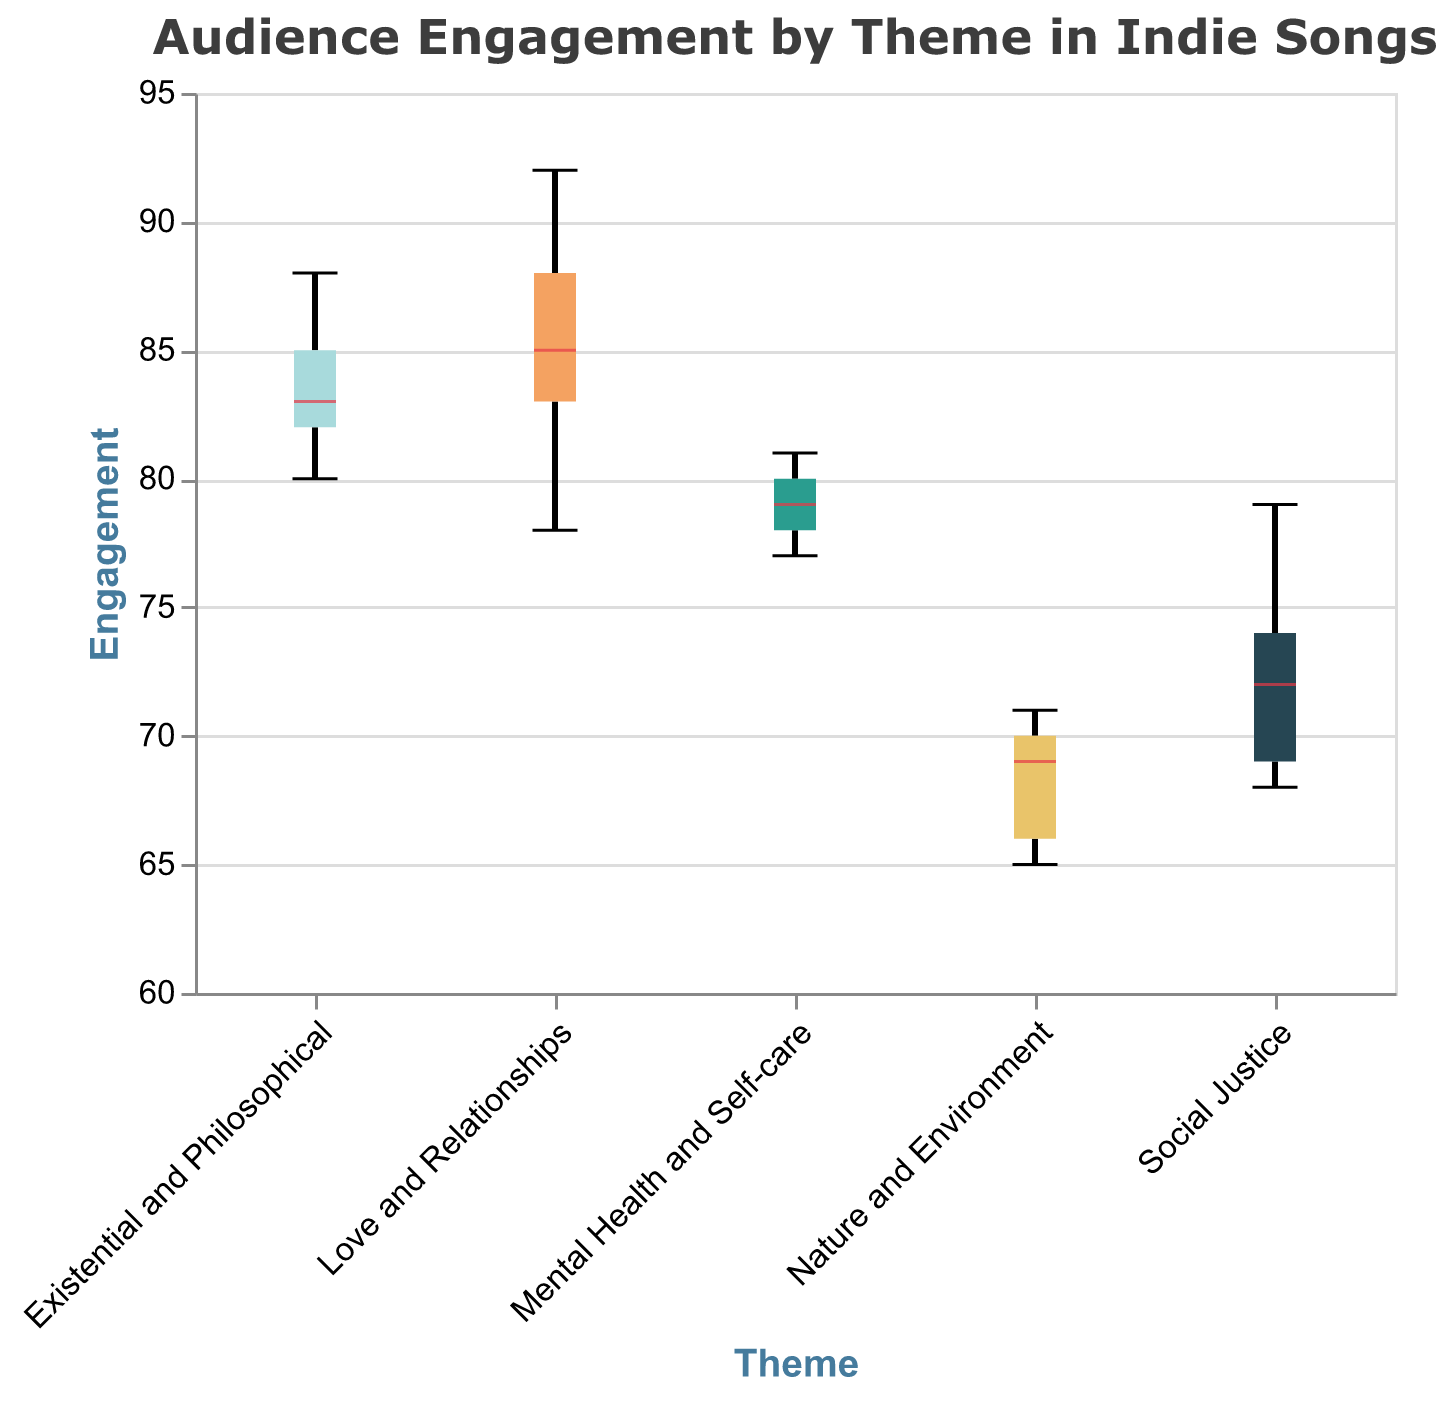What themes are compared in the notched box plot? The plot compares the themes shown on the x-axis. These are: Love and Relationships, Social Justice, Nature and Environment, Existential and Philosophical, and Mental Health and Self-care.
Answer: Love and Relationships, Social Justice, Nature and Environment, Existential and Philosophical, Mental Health and Self-care What is the title of the notched box plot? The title of the plot is displayed at the top of the figure.
Answer: Audience Engagement by Theme in Indie Songs Which theme has the highest median engagement? The median engagement level is indicated by a line in the center of each box. The highest median is shown by the box with the highest line within it.
Answer: Love and Relationships Which theme has the lowest median engagement? The lowest median engagement level can be identified by the box with the lowest line in the center of it.
Answer: Nature and Environment How does the engagement range of "Social Justice" compare to "Mental Health and Self-care"? To compare the ranges, observe the minimum and maximum points (whiskers) of both themes. Social Justice has a range approximately from 68 to 79, while Mental Health and Self-care range from about 77 to 81.
Answer: Social Justice has a wider range than Mental Health and Self-care What is the approximate interquartile range (IQR) of "Existential and Philosophical"? The IQR represents the range between the first quartile (bottom of the box) and the third quartile (top of the box). By observing these points on the plot for the "Existential and Philosophical" theme, the first quartile is around 82 and the third quartile is around 86.
Answer: About 4 Which theme has the widest interquartile range (IQR)? The widest IQR can be observed by finding the box with the largest distance between the top and bottom edges.
Answer: Social Justice Which themes have overlapping notches? In a notched box plot, overlapping notches suggest that the medians of these groups are not significantly different. By observing notches that touch or overlap, one could see overlapping regions.
Answer: Existential and Philosophical and Mental Health and Self-care Is there any theme with no visible outliers? Outliers are marked as points outside the whiskers of the boxplot. By observing the presence of points beyond the whiskers, the theme without such points is identified.
Answer: All themes (no visible outliers) Is the median engagement of "Nature and Environment" higher or lower than 70? The median is shown as a line inside the box plot. The line for "Nature and Environment" appears to be above the 70 mark on the y-axis.
Answer: Higher 